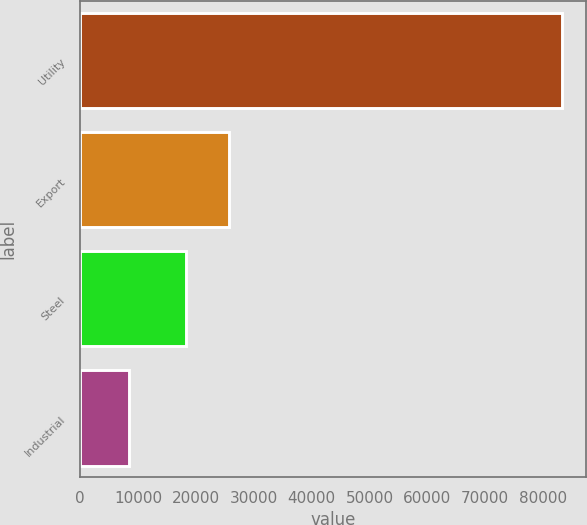Convert chart. <chart><loc_0><loc_0><loc_500><loc_500><bar_chart><fcel>Utility<fcel>Export<fcel>Steel<fcel>Industrial<nl><fcel>83225<fcel>25720.3<fcel>18236<fcel>8382<nl></chart> 